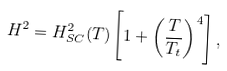Convert formula to latex. <formula><loc_0><loc_0><loc_500><loc_500>H ^ { 2 } = H _ { S C } ^ { 2 } ( T ) \left [ 1 + \left ( \frac { T } { T _ { t } } \right ) ^ { 4 } \right ] ,</formula> 